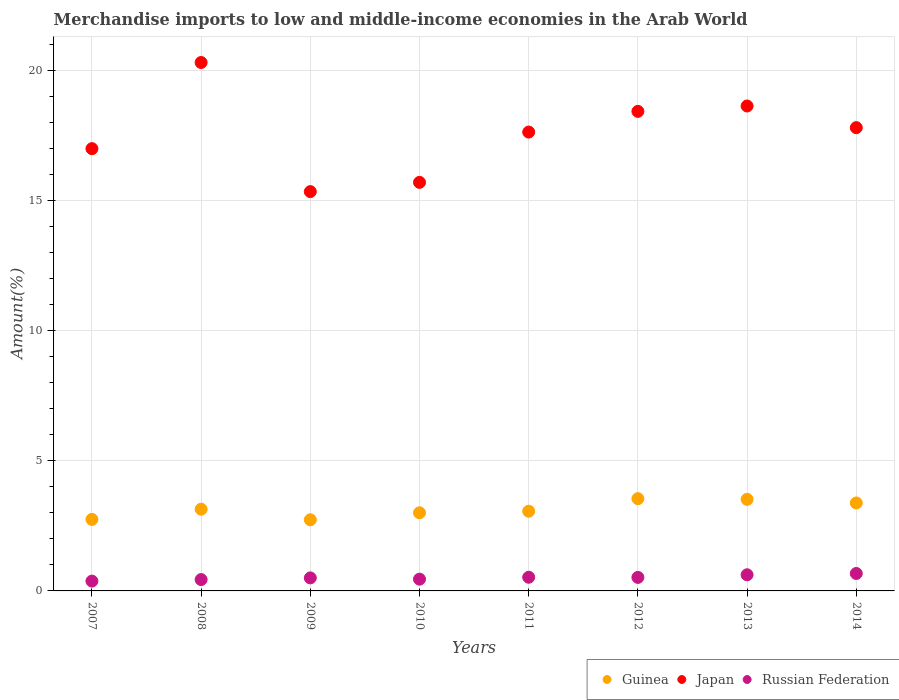Is the number of dotlines equal to the number of legend labels?
Ensure brevity in your answer.  Yes. What is the percentage of amount earned from merchandise imports in Japan in 2013?
Offer a terse response. 18.65. Across all years, what is the maximum percentage of amount earned from merchandise imports in Japan?
Make the answer very short. 20.32. Across all years, what is the minimum percentage of amount earned from merchandise imports in Russian Federation?
Keep it short and to the point. 0.38. In which year was the percentage of amount earned from merchandise imports in Japan maximum?
Provide a short and direct response. 2008. What is the total percentage of amount earned from merchandise imports in Japan in the graph?
Make the answer very short. 140.96. What is the difference between the percentage of amount earned from merchandise imports in Japan in 2011 and that in 2013?
Give a very brief answer. -1. What is the difference between the percentage of amount earned from merchandise imports in Guinea in 2011 and the percentage of amount earned from merchandise imports in Russian Federation in 2010?
Your answer should be very brief. 2.61. What is the average percentage of amount earned from merchandise imports in Guinea per year?
Give a very brief answer. 3.14. In the year 2013, what is the difference between the percentage of amount earned from merchandise imports in Japan and percentage of amount earned from merchandise imports in Guinea?
Provide a succinct answer. 15.13. In how many years, is the percentage of amount earned from merchandise imports in Guinea greater than 8 %?
Offer a terse response. 0. What is the ratio of the percentage of amount earned from merchandise imports in Japan in 2012 to that in 2014?
Make the answer very short. 1.04. What is the difference between the highest and the second highest percentage of amount earned from merchandise imports in Japan?
Provide a short and direct response. 1.67. What is the difference between the highest and the lowest percentage of amount earned from merchandise imports in Guinea?
Offer a very short reply. 0.81. Is the percentage of amount earned from merchandise imports in Japan strictly greater than the percentage of amount earned from merchandise imports in Guinea over the years?
Your response must be concise. Yes. Does the graph contain any zero values?
Offer a very short reply. No. Does the graph contain grids?
Keep it short and to the point. Yes. How many legend labels are there?
Keep it short and to the point. 3. How are the legend labels stacked?
Your response must be concise. Horizontal. What is the title of the graph?
Offer a very short reply. Merchandise imports to low and middle-income economies in the Arab World. What is the label or title of the X-axis?
Offer a very short reply. Years. What is the label or title of the Y-axis?
Ensure brevity in your answer.  Amount(%). What is the Amount(%) of Guinea in 2007?
Give a very brief answer. 2.75. What is the Amount(%) of Japan in 2007?
Provide a short and direct response. 17.01. What is the Amount(%) in Russian Federation in 2007?
Provide a short and direct response. 0.38. What is the Amount(%) in Guinea in 2008?
Provide a short and direct response. 3.14. What is the Amount(%) of Japan in 2008?
Your answer should be compact. 20.32. What is the Amount(%) of Russian Federation in 2008?
Provide a succinct answer. 0.44. What is the Amount(%) in Guinea in 2009?
Give a very brief answer. 2.74. What is the Amount(%) in Japan in 2009?
Give a very brief answer. 15.36. What is the Amount(%) in Russian Federation in 2009?
Make the answer very short. 0.5. What is the Amount(%) of Guinea in 2010?
Your answer should be very brief. 3.01. What is the Amount(%) in Japan in 2010?
Provide a succinct answer. 15.71. What is the Amount(%) of Russian Federation in 2010?
Ensure brevity in your answer.  0.45. What is the Amount(%) of Guinea in 2011?
Offer a terse response. 3.06. What is the Amount(%) of Japan in 2011?
Provide a succinct answer. 17.65. What is the Amount(%) in Russian Federation in 2011?
Your answer should be very brief. 0.53. What is the Amount(%) of Guinea in 2012?
Provide a succinct answer. 3.55. What is the Amount(%) in Japan in 2012?
Offer a terse response. 18.44. What is the Amount(%) of Russian Federation in 2012?
Your answer should be compact. 0.52. What is the Amount(%) in Guinea in 2013?
Provide a short and direct response. 3.52. What is the Amount(%) in Japan in 2013?
Your answer should be very brief. 18.65. What is the Amount(%) in Russian Federation in 2013?
Keep it short and to the point. 0.62. What is the Amount(%) in Guinea in 2014?
Your answer should be very brief. 3.38. What is the Amount(%) in Japan in 2014?
Offer a terse response. 17.82. What is the Amount(%) in Russian Federation in 2014?
Give a very brief answer. 0.67. Across all years, what is the maximum Amount(%) of Guinea?
Provide a succinct answer. 3.55. Across all years, what is the maximum Amount(%) of Japan?
Your response must be concise. 20.32. Across all years, what is the maximum Amount(%) in Russian Federation?
Offer a very short reply. 0.67. Across all years, what is the minimum Amount(%) of Guinea?
Offer a very short reply. 2.74. Across all years, what is the minimum Amount(%) in Japan?
Keep it short and to the point. 15.36. Across all years, what is the minimum Amount(%) in Russian Federation?
Make the answer very short. 0.38. What is the total Amount(%) in Guinea in the graph?
Provide a succinct answer. 25.15. What is the total Amount(%) of Japan in the graph?
Offer a very short reply. 140.96. What is the total Amount(%) of Russian Federation in the graph?
Provide a short and direct response. 4.11. What is the difference between the Amount(%) in Guinea in 2007 and that in 2008?
Give a very brief answer. -0.39. What is the difference between the Amount(%) of Japan in 2007 and that in 2008?
Provide a short and direct response. -3.31. What is the difference between the Amount(%) of Russian Federation in 2007 and that in 2008?
Give a very brief answer. -0.06. What is the difference between the Amount(%) of Guinea in 2007 and that in 2009?
Provide a short and direct response. 0.01. What is the difference between the Amount(%) in Japan in 2007 and that in 2009?
Give a very brief answer. 1.65. What is the difference between the Amount(%) in Russian Federation in 2007 and that in 2009?
Keep it short and to the point. -0.12. What is the difference between the Amount(%) in Guinea in 2007 and that in 2010?
Your answer should be very brief. -0.25. What is the difference between the Amount(%) of Japan in 2007 and that in 2010?
Offer a terse response. 1.3. What is the difference between the Amount(%) of Russian Federation in 2007 and that in 2010?
Your answer should be compact. -0.07. What is the difference between the Amount(%) in Guinea in 2007 and that in 2011?
Your response must be concise. -0.31. What is the difference between the Amount(%) in Japan in 2007 and that in 2011?
Provide a succinct answer. -0.64. What is the difference between the Amount(%) in Russian Federation in 2007 and that in 2011?
Ensure brevity in your answer.  -0.15. What is the difference between the Amount(%) of Guinea in 2007 and that in 2012?
Ensure brevity in your answer.  -0.8. What is the difference between the Amount(%) of Japan in 2007 and that in 2012?
Offer a very short reply. -1.43. What is the difference between the Amount(%) of Russian Federation in 2007 and that in 2012?
Ensure brevity in your answer.  -0.14. What is the difference between the Amount(%) in Guinea in 2007 and that in 2013?
Your response must be concise. -0.77. What is the difference between the Amount(%) in Japan in 2007 and that in 2013?
Offer a terse response. -1.64. What is the difference between the Amount(%) of Russian Federation in 2007 and that in 2013?
Your response must be concise. -0.24. What is the difference between the Amount(%) of Guinea in 2007 and that in 2014?
Your response must be concise. -0.63. What is the difference between the Amount(%) of Japan in 2007 and that in 2014?
Provide a succinct answer. -0.81. What is the difference between the Amount(%) of Russian Federation in 2007 and that in 2014?
Offer a terse response. -0.29. What is the difference between the Amount(%) in Guinea in 2008 and that in 2009?
Provide a succinct answer. 0.41. What is the difference between the Amount(%) in Japan in 2008 and that in 2009?
Give a very brief answer. 4.97. What is the difference between the Amount(%) of Russian Federation in 2008 and that in 2009?
Make the answer very short. -0.06. What is the difference between the Amount(%) in Guinea in 2008 and that in 2010?
Keep it short and to the point. 0.14. What is the difference between the Amount(%) in Japan in 2008 and that in 2010?
Make the answer very short. 4.61. What is the difference between the Amount(%) in Russian Federation in 2008 and that in 2010?
Ensure brevity in your answer.  -0.02. What is the difference between the Amount(%) in Guinea in 2008 and that in 2011?
Provide a short and direct response. 0.08. What is the difference between the Amount(%) of Japan in 2008 and that in 2011?
Keep it short and to the point. 2.68. What is the difference between the Amount(%) of Russian Federation in 2008 and that in 2011?
Provide a succinct answer. -0.09. What is the difference between the Amount(%) of Guinea in 2008 and that in 2012?
Give a very brief answer. -0.41. What is the difference between the Amount(%) of Japan in 2008 and that in 2012?
Offer a terse response. 1.88. What is the difference between the Amount(%) in Russian Federation in 2008 and that in 2012?
Your response must be concise. -0.08. What is the difference between the Amount(%) in Guinea in 2008 and that in 2013?
Offer a very short reply. -0.38. What is the difference between the Amount(%) in Japan in 2008 and that in 2013?
Provide a succinct answer. 1.67. What is the difference between the Amount(%) in Russian Federation in 2008 and that in 2013?
Make the answer very short. -0.18. What is the difference between the Amount(%) in Guinea in 2008 and that in 2014?
Keep it short and to the point. -0.24. What is the difference between the Amount(%) of Japan in 2008 and that in 2014?
Provide a succinct answer. 2.5. What is the difference between the Amount(%) of Russian Federation in 2008 and that in 2014?
Give a very brief answer. -0.23. What is the difference between the Amount(%) of Guinea in 2009 and that in 2010?
Provide a short and direct response. -0.27. What is the difference between the Amount(%) of Japan in 2009 and that in 2010?
Make the answer very short. -0.36. What is the difference between the Amount(%) in Russian Federation in 2009 and that in 2010?
Give a very brief answer. 0.05. What is the difference between the Amount(%) of Guinea in 2009 and that in 2011?
Ensure brevity in your answer.  -0.33. What is the difference between the Amount(%) of Japan in 2009 and that in 2011?
Your answer should be very brief. -2.29. What is the difference between the Amount(%) in Russian Federation in 2009 and that in 2011?
Make the answer very short. -0.02. What is the difference between the Amount(%) in Guinea in 2009 and that in 2012?
Keep it short and to the point. -0.81. What is the difference between the Amount(%) of Japan in 2009 and that in 2012?
Your response must be concise. -3.09. What is the difference between the Amount(%) of Russian Federation in 2009 and that in 2012?
Ensure brevity in your answer.  -0.02. What is the difference between the Amount(%) in Guinea in 2009 and that in 2013?
Your response must be concise. -0.79. What is the difference between the Amount(%) in Japan in 2009 and that in 2013?
Your response must be concise. -3.29. What is the difference between the Amount(%) in Russian Federation in 2009 and that in 2013?
Make the answer very short. -0.12. What is the difference between the Amount(%) of Guinea in 2009 and that in 2014?
Your answer should be compact. -0.65. What is the difference between the Amount(%) of Japan in 2009 and that in 2014?
Offer a terse response. -2.46. What is the difference between the Amount(%) in Russian Federation in 2009 and that in 2014?
Your answer should be very brief. -0.17. What is the difference between the Amount(%) of Guinea in 2010 and that in 2011?
Keep it short and to the point. -0.06. What is the difference between the Amount(%) of Japan in 2010 and that in 2011?
Offer a terse response. -1.93. What is the difference between the Amount(%) in Russian Federation in 2010 and that in 2011?
Give a very brief answer. -0.07. What is the difference between the Amount(%) in Guinea in 2010 and that in 2012?
Keep it short and to the point. -0.54. What is the difference between the Amount(%) of Japan in 2010 and that in 2012?
Provide a short and direct response. -2.73. What is the difference between the Amount(%) in Russian Federation in 2010 and that in 2012?
Ensure brevity in your answer.  -0.07. What is the difference between the Amount(%) of Guinea in 2010 and that in 2013?
Offer a terse response. -0.52. What is the difference between the Amount(%) of Japan in 2010 and that in 2013?
Provide a short and direct response. -2.94. What is the difference between the Amount(%) in Russian Federation in 2010 and that in 2013?
Offer a terse response. -0.17. What is the difference between the Amount(%) in Guinea in 2010 and that in 2014?
Your answer should be very brief. -0.38. What is the difference between the Amount(%) in Japan in 2010 and that in 2014?
Give a very brief answer. -2.1. What is the difference between the Amount(%) of Russian Federation in 2010 and that in 2014?
Provide a short and direct response. -0.22. What is the difference between the Amount(%) of Guinea in 2011 and that in 2012?
Keep it short and to the point. -0.48. What is the difference between the Amount(%) in Japan in 2011 and that in 2012?
Offer a very short reply. -0.8. What is the difference between the Amount(%) of Russian Federation in 2011 and that in 2012?
Offer a terse response. 0.01. What is the difference between the Amount(%) of Guinea in 2011 and that in 2013?
Offer a very short reply. -0.46. What is the difference between the Amount(%) of Japan in 2011 and that in 2013?
Your answer should be very brief. -1. What is the difference between the Amount(%) of Russian Federation in 2011 and that in 2013?
Provide a succinct answer. -0.1. What is the difference between the Amount(%) in Guinea in 2011 and that in 2014?
Make the answer very short. -0.32. What is the difference between the Amount(%) in Japan in 2011 and that in 2014?
Your answer should be compact. -0.17. What is the difference between the Amount(%) of Russian Federation in 2011 and that in 2014?
Your answer should be very brief. -0.15. What is the difference between the Amount(%) of Guinea in 2012 and that in 2013?
Give a very brief answer. 0.03. What is the difference between the Amount(%) of Japan in 2012 and that in 2013?
Your answer should be compact. -0.21. What is the difference between the Amount(%) of Russian Federation in 2012 and that in 2013?
Give a very brief answer. -0.1. What is the difference between the Amount(%) of Guinea in 2012 and that in 2014?
Offer a terse response. 0.17. What is the difference between the Amount(%) in Japan in 2012 and that in 2014?
Keep it short and to the point. 0.63. What is the difference between the Amount(%) in Russian Federation in 2012 and that in 2014?
Your answer should be compact. -0.15. What is the difference between the Amount(%) in Guinea in 2013 and that in 2014?
Provide a succinct answer. 0.14. What is the difference between the Amount(%) of Japan in 2013 and that in 2014?
Keep it short and to the point. 0.83. What is the difference between the Amount(%) of Russian Federation in 2013 and that in 2014?
Offer a terse response. -0.05. What is the difference between the Amount(%) in Guinea in 2007 and the Amount(%) in Japan in 2008?
Provide a succinct answer. -17.57. What is the difference between the Amount(%) in Guinea in 2007 and the Amount(%) in Russian Federation in 2008?
Your response must be concise. 2.31. What is the difference between the Amount(%) in Japan in 2007 and the Amount(%) in Russian Federation in 2008?
Your answer should be very brief. 16.57. What is the difference between the Amount(%) of Guinea in 2007 and the Amount(%) of Japan in 2009?
Offer a terse response. -12.61. What is the difference between the Amount(%) in Guinea in 2007 and the Amount(%) in Russian Federation in 2009?
Offer a very short reply. 2.25. What is the difference between the Amount(%) in Japan in 2007 and the Amount(%) in Russian Federation in 2009?
Make the answer very short. 16.51. What is the difference between the Amount(%) of Guinea in 2007 and the Amount(%) of Japan in 2010?
Make the answer very short. -12.96. What is the difference between the Amount(%) in Guinea in 2007 and the Amount(%) in Russian Federation in 2010?
Make the answer very short. 2.3. What is the difference between the Amount(%) in Japan in 2007 and the Amount(%) in Russian Federation in 2010?
Your answer should be compact. 16.56. What is the difference between the Amount(%) of Guinea in 2007 and the Amount(%) of Japan in 2011?
Offer a terse response. -14.9. What is the difference between the Amount(%) in Guinea in 2007 and the Amount(%) in Russian Federation in 2011?
Your answer should be very brief. 2.23. What is the difference between the Amount(%) of Japan in 2007 and the Amount(%) of Russian Federation in 2011?
Provide a succinct answer. 16.48. What is the difference between the Amount(%) of Guinea in 2007 and the Amount(%) of Japan in 2012?
Give a very brief answer. -15.69. What is the difference between the Amount(%) in Guinea in 2007 and the Amount(%) in Russian Federation in 2012?
Give a very brief answer. 2.23. What is the difference between the Amount(%) of Japan in 2007 and the Amount(%) of Russian Federation in 2012?
Your answer should be compact. 16.49. What is the difference between the Amount(%) in Guinea in 2007 and the Amount(%) in Japan in 2013?
Offer a very short reply. -15.9. What is the difference between the Amount(%) in Guinea in 2007 and the Amount(%) in Russian Federation in 2013?
Provide a succinct answer. 2.13. What is the difference between the Amount(%) of Japan in 2007 and the Amount(%) of Russian Federation in 2013?
Your response must be concise. 16.39. What is the difference between the Amount(%) of Guinea in 2007 and the Amount(%) of Japan in 2014?
Your answer should be very brief. -15.07. What is the difference between the Amount(%) of Guinea in 2007 and the Amount(%) of Russian Federation in 2014?
Provide a short and direct response. 2.08. What is the difference between the Amount(%) of Japan in 2007 and the Amount(%) of Russian Federation in 2014?
Give a very brief answer. 16.34. What is the difference between the Amount(%) of Guinea in 2008 and the Amount(%) of Japan in 2009?
Offer a very short reply. -12.21. What is the difference between the Amount(%) of Guinea in 2008 and the Amount(%) of Russian Federation in 2009?
Provide a short and direct response. 2.64. What is the difference between the Amount(%) of Japan in 2008 and the Amount(%) of Russian Federation in 2009?
Your answer should be compact. 19.82. What is the difference between the Amount(%) in Guinea in 2008 and the Amount(%) in Japan in 2010?
Make the answer very short. -12.57. What is the difference between the Amount(%) of Guinea in 2008 and the Amount(%) of Russian Federation in 2010?
Offer a terse response. 2.69. What is the difference between the Amount(%) in Japan in 2008 and the Amount(%) in Russian Federation in 2010?
Give a very brief answer. 19.87. What is the difference between the Amount(%) of Guinea in 2008 and the Amount(%) of Japan in 2011?
Provide a short and direct response. -14.5. What is the difference between the Amount(%) of Guinea in 2008 and the Amount(%) of Russian Federation in 2011?
Ensure brevity in your answer.  2.62. What is the difference between the Amount(%) in Japan in 2008 and the Amount(%) in Russian Federation in 2011?
Make the answer very short. 19.8. What is the difference between the Amount(%) of Guinea in 2008 and the Amount(%) of Japan in 2012?
Give a very brief answer. -15.3. What is the difference between the Amount(%) in Guinea in 2008 and the Amount(%) in Russian Federation in 2012?
Provide a short and direct response. 2.62. What is the difference between the Amount(%) in Japan in 2008 and the Amount(%) in Russian Federation in 2012?
Ensure brevity in your answer.  19.8. What is the difference between the Amount(%) of Guinea in 2008 and the Amount(%) of Japan in 2013?
Your answer should be very brief. -15.51. What is the difference between the Amount(%) of Guinea in 2008 and the Amount(%) of Russian Federation in 2013?
Your response must be concise. 2.52. What is the difference between the Amount(%) of Japan in 2008 and the Amount(%) of Russian Federation in 2013?
Offer a terse response. 19.7. What is the difference between the Amount(%) of Guinea in 2008 and the Amount(%) of Japan in 2014?
Offer a very short reply. -14.67. What is the difference between the Amount(%) in Guinea in 2008 and the Amount(%) in Russian Federation in 2014?
Your response must be concise. 2.47. What is the difference between the Amount(%) in Japan in 2008 and the Amount(%) in Russian Federation in 2014?
Your answer should be compact. 19.65. What is the difference between the Amount(%) of Guinea in 2009 and the Amount(%) of Japan in 2010?
Your answer should be compact. -12.98. What is the difference between the Amount(%) in Guinea in 2009 and the Amount(%) in Russian Federation in 2010?
Your answer should be very brief. 2.28. What is the difference between the Amount(%) of Japan in 2009 and the Amount(%) of Russian Federation in 2010?
Provide a short and direct response. 14.91. What is the difference between the Amount(%) in Guinea in 2009 and the Amount(%) in Japan in 2011?
Provide a succinct answer. -14.91. What is the difference between the Amount(%) of Guinea in 2009 and the Amount(%) of Russian Federation in 2011?
Ensure brevity in your answer.  2.21. What is the difference between the Amount(%) in Japan in 2009 and the Amount(%) in Russian Federation in 2011?
Provide a short and direct response. 14.83. What is the difference between the Amount(%) of Guinea in 2009 and the Amount(%) of Japan in 2012?
Offer a very short reply. -15.71. What is the difference between the Amount(%) of Guinea in 2009 and the Amount(%) of Russian Federation in 2012?
Ensure brevity in your answer.  2.22. What is the difference between the Amount(%) of Japan in 2009 and the Amount(%) of Russian Federation in 2012?
Your response must be concise. 14.84. What is the difference between the Amount(%) in Guinea in 2009 and the Amount(%) in Japan in 2013?
Your answer should be very brief. -15.91. What is the difference between the Amount(%) in Guinea in 2009 and the Amount(%) in Russian Federation in 2013?
Provide a short and direct response. 2.12. What is the difference between the Amount(%) of Japan in 2009 and the Amount(%) of Russian Federation in 2013?
Provide a short and direct response. 14.74. What is the difference between the Amount(%) in Guinea in 2009 and the Amount(%) in Japan in 2014?
Give a very brief answer. -15.08. What is the difference between the Amount(%) of Guinea in 2009 and the Amount(%) of Russian Federation in 2014?
Your answer should be very brief. 2.07. What is the difference between the Amount(%) of Japan in 2009 and the Amount(%) of Russian Federation in 2014?
Keep it short and to the point. 14.69. What is the difference between the Amount(%) in Guinea in 2010 and the Amount(%) in Japan in 2011?
Your response must be concise. -14.64. What is the difference between the Amount(%) in Guinea in 2010 and the Amount(%) in Russian Federation in 2011?
Give a very brief answer. 2.48. What is the difference between the Amount(%) of Japan in 2010 and the Amount(%) of Russian Federation in 2011?
Give a very brief answer. 15.19. What is the difference between the Amount(%) of Guinea in 2010 and the Amount(%) of Japan in 2012?
Ensure brevity in your answer.  -15.44. What is the difference between the Amount(%) of Guinea in 2010 and the Amount(%) of Russian Federation in 2012?
Ensure brevity in your answer.  2.49. What is the difference between the Amount(%) in Japan in 2010 and the Amount(%) in Russian Federation in 2012?
Make the answer very short. 15.19. What is the difference between the Amount(%) of Guinea in 2010 and the Amount(%) of Japan in 2013?
Make the answer very short. -15.64. What is the difference between the Amount(%) in Guinea in 2010 and the Amount(%) in Russian Federation in 2013?
Provide a short and direct response. 2.38. What is the difference between the Amount(%) in Japan in 2010 and the Amount(%) in Russian Federation in 2013?
Provide a short and direct response. 15.09. What is the difference between the Amount(%) of Guinea in 2010 and the Amount(%) of Japan in 2014?
Keep it short and to the point. -14.81. What is the difference between the Amount(%) of Guinea in 2010 and the Amount(%) of Russian Federation in 2014?
Your answer should be compact. 2.33. What is the difference between the Amount(%) of Japan in 2010 and the Amount(%) of Russian Federation in 2014?
Your answer should be very brief. 15.04. What is the difference between the Amount(%) of Guinea in 2011 and the Amount(%) of Japan in 2012?
Your answer should be compact. -15.38. What is the difference between the Amount(%) of Guinea in 2011 and the Amount(%) of Russian Federation in 2012?
Keep it short and to the point. 2.54. What is the difference between the Amount(%) in Japan in 2011 and the Amount(%) in Russian Federation in 2012?
Your answer should be very brief. 17.13. What is the difference between the Amount(%) in Guinea in 2011 and the Amount(%) in Japan in 2013?
Offer a terse response. -15.58. What is the difference between the Amount(%) of Guinea in 2011 and the Amount(%) of Russian Federation in 2013?
Your answer should be compact. 2.44. What is the difference between the Amount(%) in Japan in 2011 and the Amount(%) in Russian Federation in 2013?
Your answer should be compact. 17.03. What is the difference between the Amount(%) in Guinea in 2011 and the Amount(%) in Japan in 2014?
Offer a very short reply. -14.75. What is the difference between the Amount(%) in Guinea in 2011 and the Amount(%) in Russian Federation in 2014?
Your answer should be compact. 2.39. What is the difference between the Amount(%) of Japan in 2011 and the Amount(%) of Russian Federation in 2014?
Make the answer very short. 16.98. What is the difference between the Amount(%) of Guinea in 2012 and the Amount(%) of Japan in 2013?
Offer a very short reply. -15.1. What is the difference between the Amount(%) of Guinea in 2012 and the Amount(%) of Russian Federation in 2013?
Provide a short and direct response. 2.93. What is the difference between the Amount(%) of Japan in 2012 and the Amount(%) of Russian Federation in 2013?
Provide a succinct answer. 17.82. What is the difference between the Amount(%) in Guinea in 2012 and the Amount(%) in Japan in 2014?
Keep it short and to the point. -14.27. What is the difference between the Amount(%) of Guinea in 2012 and the Amount(%) of Russian Federation in 2014?
Your response must be concise. 2.88. What is the difference between the Amount(%) in Japan in 2012 and the Amount(%) in Russian Federation in 2014?
Your answer should be very brief. 17.77. What is the difference between the Amount(%) in Guinea in 2013 and the Amount(%) in Japan in 2014?
Keep it short and to the point. -14.3. What is the difference between the Amount(%) in Guinea in 2013 and the Amount(%) in Russian Federation in 2014?
Keep it short and to the point. 2.85. What is the difference between the Amount(%) of Japan in 2013 and the Amount(%) of Russian Federation in 2014?
Offer a terse response. 17.98. What is the average Amount(%) in Guinea per year?
Give a very brief answer. 3.14. What is the average Amount(%) of Japan per year?
Keep it short and to the point. 17.62. What is the average Amount(%) of Russian Federation per year?
Ensure brevity in your answer.  0.51. In the year 2007, what is the difference between the Amount(%) of Guinea and Amount(%) of Japan?
Your answer should be very brief. -14.26. In the year 2007, what is the difference between the Amount(%) in Guinea and Amount(%) in Russian Federation?
Offer a terse response. 2.37. In the year 2007, what is the difference between the Amount(%) of Japan and Amount(%) of Russian Federation?
Your answer should be very brief. 16.63. In the year 2008, what is the difference between the Amount(%) in Guinea and Amount(%) in Japan?
Offer a very short reply. -17.18. In the year 2008, what is the difference between the Amount(%) of Guinea and Amount(%) of Russian Federation?
Keep it short and to the point. 2.71. In the year 2008, what is the difference between the Amount(%) in Japan and Amount(%) in Russian Federation?
Your response must be concise. 19.89. In the year 2009, what is the difference between the Amount(%) of Guinea and Amount(%) of Japan?
Offer a terse response. -12.62. In the year 2009, what is the difference between the Amount(%) in Guinea and Amount(%) in Russian Federation?
Ensure brevity in your answer.  2.24. In the year 2009, what is the difference between the Amount(%) in Japan and Amount(%) in Russian Federation?
Give a very brief answer. 14.86. In the year 2010, what is the difference between the Amount(%) of Guinea and Amount(%) of Japan?
Offer a terse response. -12.71. In the year 2010, what is the difference between the Amount(%) in Guinea and Amount(%) in Russian Federation?
Provide a succinct answer. 2.55. In the year 2010, what is the difference between the Amount(%) of Japan and Amount(%) of Russian Federation?
Offer a very short reply. 15.26. In the year 2011, what is the difference between the Amount(%) in Guinea and Amount(%) in Japan?
Give a very brief answer. -14.58. In the year 2011, what is the difference between the Amount(%) in Guinea and Amount(%) in Russian Federation?
Provide a short and direct response. 2.54. In the year 2011, what is the difference between the Amount(%) of Japan and Amount(%) of Russian Federation?
Ensure brevity in your answer.  17.12. In the year 2012, what is the difference between the Amount(%) in Guinea and Amount(%) in Japan?
Provide a short and direct response. -14.9. In the year 2012, what is the difference between the Amount(%) of Guinea and Amount(%) of Russian Federation?
Give a very brief answer. 3.03. In the year 2012, what is the difference between the Amount(%) in Japan and Amount(%) in Russian Federation?
Your answer should be compact. 17.92. In the year 2013, what is the difference between the Amount(%) of Guinea and Amount(%) of Japan?
Your response must be concise. -15.13. In the year 2013, what is the difference between the Amount(%) in Guinea and Amount(%) in Russian Federation?
Offer a terse response. 2.9. In the year 2013, what is the difference between the Amount(%) of Japan and Amount(%) of Russian Federation?
Keep it short and to the point. 18.03. In the year 2014, what is the difference between the Amount(%) of Guinea and Amount(%) of Japan?
Your answer should be very brief. -14.44. In the year 2014, what is the difference between the Amount(%) in Guinea and Amount(%) in Russian Federation?
Provide a succinct answer. 2.71. In the year 2014, what is the difference between the Amount(%) of Japan and Amount(%) of Russian Federation?
Offer a very short reply. 17.15. What is the ratio of the Amount(%) of Guinea in 2007 to that in 2008?
Keep it short and to the point. 0.88. What is the ratio of the Amount(%) in Japan in 2007 to that in 2008?
Give a very brief answer. 0.84. What is the ratio of the Amount(%) in Russian Federation in 2007 to that in 2008?
Provide a short and direct response. 0.87. What is the ratio of the Amount(%) in Japan in 2007 to that in 2009?
Make the answer very short. 1.11. What is the ratio of the Amount(%) in Russian Federation in 2007 to that in 2009?
Your answer should be very brief. 0.75. What is the ratio of the Amount(%) of Guinea in 2007 to that in 2010?
Ensure brevity in your answer.  0.92. What is the ratio of the Amount(%) of Japan in 2007 to that in 2010?
Provide a short and direct response. 1.08. What is the ratio of the Amount(%) in Russian Federation in 2007 to that in 2010?
Give a very brief answer. 0.84. What is the ratio of the Amount(%) in Guinea in 2007 to that in 2011?
Offer a very short reply. 0.9. What is the ratio of the Amount(%) of Japan in 2007 to that in 2011?
Give a very brief answer. 0.96. What is the ratio of the Amount(%) in Russian Federation in 2007 to that in 2011?
Keep it short and to the point. 0.72. What is the ratio of the Amount(%) in Guinea in 2007 to that in 2012?
Ensure brevity in your answer.  0.78. What is the ratio of the Amount(%) in Japan in 2007 to that in 2012?
Your answer should be very brief. 0.92. What is the ratio of the Amount(%) in Russian Federation in 2007 to that in 2012?
Your answer should be compact. 0.73. What is the ratio of the Amount(%) of Guinea in 2007 to that in 2013?
Offer a terse response. 0.78. What is the ratio of the Amount(%) of Japan in 2007 to that in 2013?
Your answer should be very brief. 0.91. What is the ratio of the Amount(%) in Russian Federation in 2007 to that in 2013?
Provide a succinct answer. 0.61. What is the ratio of the Amount(%) in Guinea in 2007 to that in 2014?
Provide a succinct answer. 0.81. What is the ratio of the Amount(%) in Japan in 2007 to that in 2014?
Give a very brief answer. 0.95. What is the ratio of the Amount(%) in Russian Federation in 2007 to that in 2014?
Make the answer very short. 0.56. What is the ratio of the Amount(%) of Guinea in 2008 to that in 2009?
Your answer should be compact. 1.15. What is the ratio of the Amount(%) in Japan in 2008 to that in 2009?
Your answer should be compact. 1.32. What is the ratio of the Amount(%) in Russian Federation in 2008 to that in 2009?
Provide a short and direct response. 0.87. What is the ratio of the Amount(%) of Guinea in 2008 to that in 2010?
Provide a succinct answer. 1.05. What is the ratio of the Amount(%) in Japan in 2008 to that in 2010?
Your response must be concise. 1.29. What is the ratio of the Amount(%) in Russian Federation in 2008 to that in 2010?
Your answer should be compact. 0.97. What is the ratio of the Amount(%) in Guinea in 2008 to that in 2011?
Provide a succinct answer. 1.03. What is the ratio of the Amount(%) of Japan in 2008 to that in 2011?
Your answer should be very brief. 1.15. What is the ratio of the Amount(%) of Russian Federation in 2008 to that in 2011?
Your answer should be very brief. 0.83. What is the ratio of the Amount(%) of Guinea in 2008 to that in 2012?
Provide a succinct answer. 0.89. What is the ratio of the Amount(%) in Japan in 2008 to that in 2012?
Your response must be concise. 1.1. What is the ratio of the Amount(%) in Russian Federation in 2008 to that in 2012?
Your answer should be very brief. 0.84. What is the ratio of the Amount(%) of Guinea in 2008 to that in 2013?
Make the answer very short. 0.89. What is the ratio of the Amount(%) of Japan in 2008 to that in 2013?
Your answer should be compact. 1.09. What is the ratio of the Amount(%) in Russian Federation in 2008 to that in 2013?
Offer a very short reply. 0.7. What is the ratio of the Amount(%) of Guinea in 2008 to that in 2014?
Make the answer very short. 0.93. What is the ratio of the Amount(%) in Japan in 2008 to that in 2014?
Your answer should be very brief. 1.14. What is the ratio of the Amount(%) of Russian Federation in 2008 to that in 2014?
Provide a succinct answer. 0.65. What is the ratio of the Amount(%) of Guinea in 2009 to that in 2010?
Your answer should be compact. 0.91. What is the ratio of the Amount(%) in Japan in 2009 to that in 2010?
Keep it short and to the point. 0.98. What is the ratio of the Amount(%) of Russian Federation in 2009 to that in 2010?
Ensure brevity in your answer.  1.11. What is the ratio of the Amount(%) of Guinea in 2009 to that in 2011?
Your answer should be compact. 0.89. What is the ratio of the Amount(%) of Japan in 2009 to that in 2011?
Keep it short and to the point. 0.87. What is the ratio of the Amount(%) in Russian Federation in 2009 to that in 2011?
Your answer should be compact. 0.95. What is the ratio of the Amount(%) in Guinea in 2009 to that in 2012?
Provide a short and direct response. 0.77. What is the ratio of the Amount(%) of Japan in 2009 to that in 2012?
Your answer should be very brief. 0.83. What is the ratio of the Amount(%) in Russian Federation in 2009 to that in 2012?
Provide a succinct answer. 0.96. What is the ratio of the Amount(%) in Guinea in 2009 to that in 2013?
Your answer should be very brief. 0.78. What is the ratio of the Amount(%) of Japan in 2009 to that in 2013?
Make the answer very short. 0.82. What is the ratio of the Amount(%) of Russian Federation in 2009 to that in 2013?
Ensure brevity in your answer.  0.81. What is the ratio of the Amount(%) of Guinea in 2009 to that in 2014?
Offer a very short reply. 0.81. What is the ratio of the Amount(%) in Japan in 2009 to that in 2014?
Offer a terse response. 0.86. What is the ratio of the Amount(%) in Russian Federation in 2009 to that in 2014?
Your response must be concise. 0.75. What is the ratio of the Amount(%) in Guinea in 2010 to that in 2011?
Provide a succinct answer. 0.98. What is the ratio of the Amount(%) in Japan in 2010 to that in 2011?
Offer a very short reply. 0.89. What is the ratio of the Amount(%) of Russian Federation in 2010 to that in 2011?
Give a very brief answer. 0.86. What is the ratio of the Amount(%) of Guinea in 2010 to that in 2012?
Your response must be concise. 0.85. What is the ratio of the Amount(%) of Japan in 2010 to that in 2012?
Make the answer very short. 0.85. What is the ratio of the Amount(%) of Russian Federation in 2010 to that in 2012?
Give a very brief answer. 0.87. What is the ratio of the Amount(%) in Guinea in 2010 to that in 2013?
Provide a succinct answer. 0.85. What is the ratio of the Amount(%) in Japan in 2010 to that in 2013?
Your answer should be compact. 0.84. What is the ratio of the Amount(%) in Russian Federation in 2010 to that in 2013?
Ensure brevity in your answer.  0.73. What is the ratio of the Amount(%) in Guinea in 2010 to that in 2014?
Offer a terse response. 0.89. What is the ratio of the Amount(%) of Japan in 2010 to that in 2014?
Your answer should be very brief. 0.88. What is the ratio of the Amount(%) of Russian Federation in 2010 to that in 2014?
Your answer should be very brief. 0.67. What is the ratio of the Amount(%) of Guinea in 2011 to that in 2012?
Offer a very short reply. 0.86. What is the ratio of the Amount(%) in Japan in 2011 to that in 2012?
Give a very brief answer. 0.96. What is the ratio of the Amount(%) in Russian Federation in 2011 to that in 2012?
Offer a terse response. 1.01. What is the ratio of the Amount(%) of Guinea in 2011 to that in 2013?
Offer a terse response. 0.87. What is the ratio of the Amount(%) of Japan in 2011 to that in 2013?
Offer a very short reply. 0.95. What is the ratio of the Amount(%) in Russian Federation in 2011 to that in 2013?
Offer a very short reply. 0.85. What is the ratio of the Amount(%) of Guinea in 2011 to that in 2014?
Offer a terse response. 0.91. What is the ratio of the Amount(%) in Japan in 2011 to that in 2014?
Offer a very short reply. 0.99. What is the ratio of the Amount(%) of Russian Federation in 2011 to that in 2014?
Your response must be concise. 0.78. What is the ratio of the Amount(%) in Guinea in 2012 to that in 2013?
Ensure brevity in your answer.  1.01. What is the ratio of the Amount(%) of Japan in 2012 to that in 2013?
Make the answer very short. 0.99. What is the ratio of the Amount(%) of Russian Federation in 2012 to that in 2013?
Your answer should be compact. 0.84. What is the ratio of the Amount(%) of Guinea in 2012 to that in 2014?
Make the answer very short. 1.05. What is the ratio of the Amount(%) in Japan in 2012 to that in 2014?
Provide a succinct answer. 1.04. What is the ratio of the Amount(%) of Russian Federation in 2012 to that in 2014?
Keep it short and to the point. 0.78. What is the ratio of the Amount(%) of Guinea in 2013 to that in 2014?
Offer a terse response. 1.04. What is the ratio of the Amount(%) in Japan in 2013 to that in 2014?
Your answer should be very brief. 1.05. What is the ratio of the Amount(%) of Russian Federation in 2013 to that in 2014?
Your answer should be compact. 0.93. What is the difference between the highest and the second highest Amount(%) in Guinea?
Offer a very short reply. 0.03. What is the difference between the highest and the second highest Amount(%) in Japan?
Offer a very short reply. 1.67. What is the difference between the highest and the second highest Amount(%) in Russian Federation?
Give a very brief answer. 0.05. What is the difference between the highest and the lowest Amount(%) of Guinea?
Keep it short and to the point. 0.81. What is the difference between the highest and the lowest Amount(%) of Japan?
Your response must be concise. 4.97. What is the difference between the highest and the lowest Amount(%) in Russian Federation?
Your response must be concise. 0.29. 